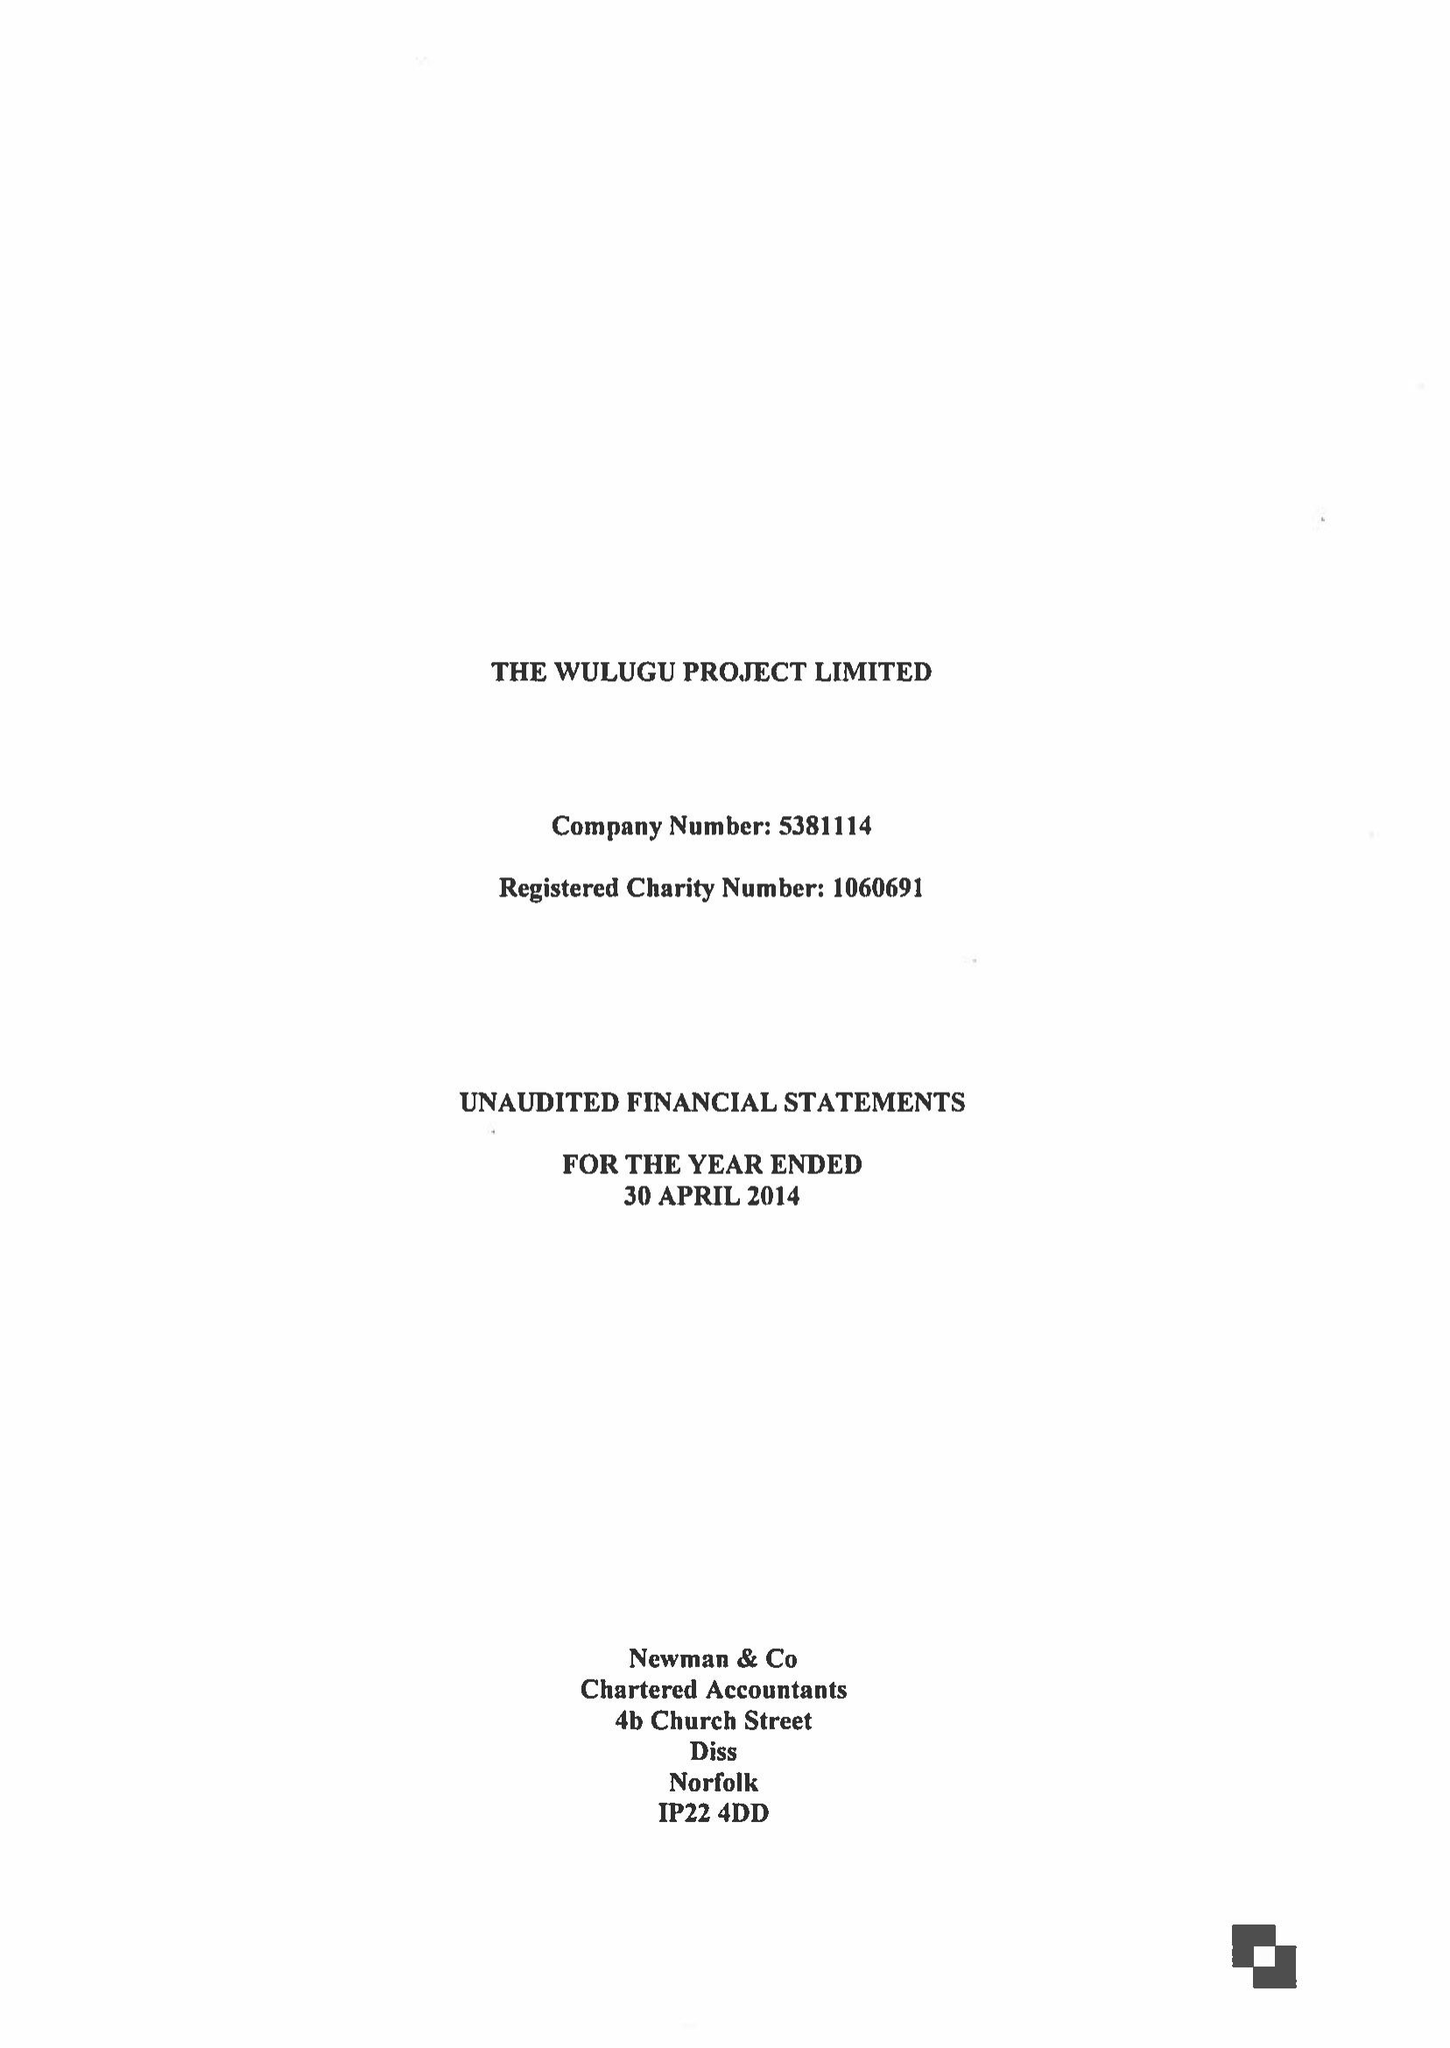What is the value for the address__postcode?
Answer the question using a single word or phrase. NR9 3BH 